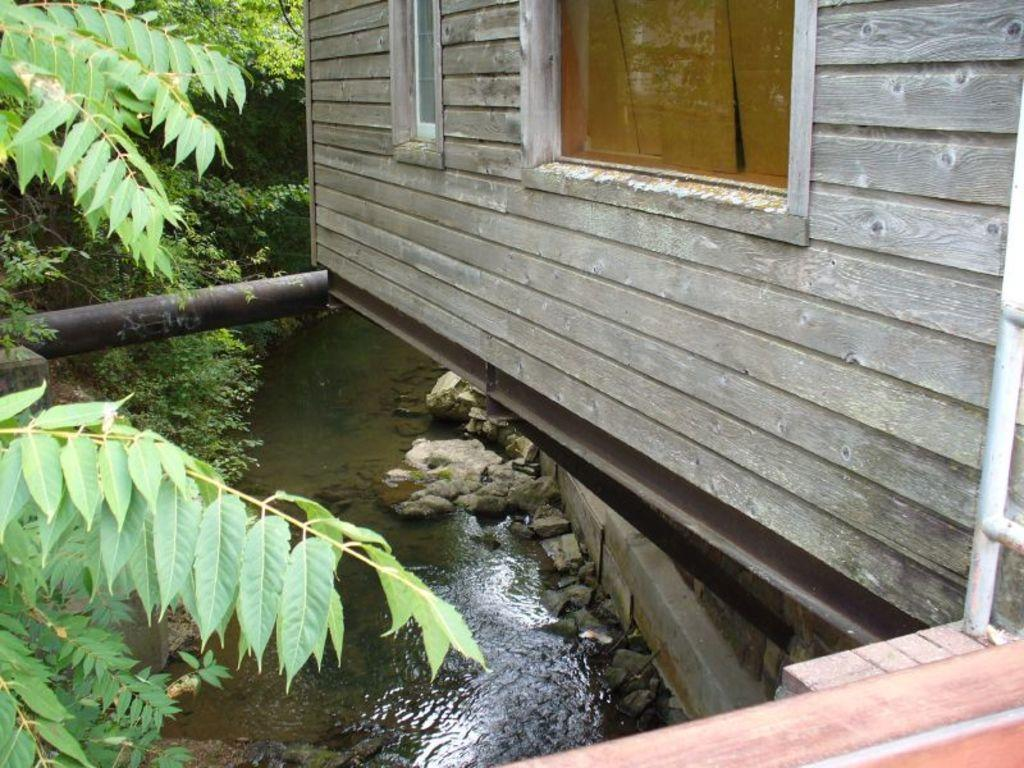What is the main subject of the image? The main subject of the image is the backside view of a house. Are there any specific features of the house that can be seen in the image? Yes, there is a window visible on the house. What can be seen in the background of the image? In the background of the image, there are trees and water visible. Can you tell me how many fairies are flying around the house in the image? There are no fairies present in the image; it only shows the backside view of a house with a window, trees, and water in the background. What type of bulb is used to light up the house in the image? There is no information about the type of bulb used to light up the house in the image, as it only shows the exterior of the house. 